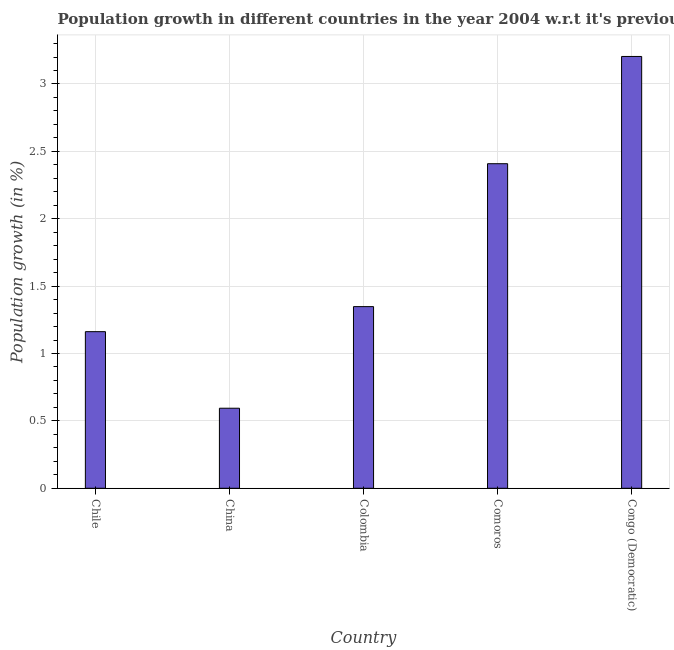Does the graph contain any zero values?
Provide a short and direct response. No. Does the graph contain grids?
Keep it short and to the point. Yes. What is the title of the graph?
Provide a short and direct response. Population growth in different countries in the year 2004 w.r.t it's previous year. What is the label or title of the Y-axis?
Keep it short and to the point. Population growth (in %). What is the population growth in Congo (Democratic)?
Give a very brief answer. 3.2. Across all countries, what is the maximum population growth?
Keep it short and to the point. 3.2. Across all countries, what is the minimum population growth?
Offer a very short reply. 0.59. In which country was the population growth maximum?
Keep it short and to the point. Congo (Democratic). In which country was the population growth minimum?
Keep it short and to the point. China. What is the sum of the population growth?
Give a very brief answer. 8.72. What is the difference between the population growth in Chile and Comoros?
Give a very brief answer. -1.25. What is the average population growth per country?
Provide a short and direct response. 1.74. What is the median population growth?
Your response must be concise. 1.35. What is the ratio of the population growth in Colombia to that in Congo (Democratic)?
Your answer should be compact. 0.42. What is the difference between the highest and the second highest population growth?
Give a very brief answer. 0.8. What is the difference between the highest and the lowest population growth?
Make the answer very short. 2.61. What is the Population growth (in %) of Chile?
Provide a short and direct response. 1.16. What is the Population growth (in %) of China?
Make the answer very short. 0.59. What is the Population growth (in %) of Colombia?
Provide a short and direct response. 1.35. What is the Population growth (in %) in Comoros?
Make the answer very short. 2.41. What is the Population growth (in %) of Congo (Democratic)?
Make the answer very short. 3.2. What is the difference between the Population growth (in %) in Chile and China?
Your answer should be very brief. 0.57. What is the difference between the Population growth (in %) in Chile and Colombia?
Your response must be concise. -0.19. What is the difference between the Population growth (in %) in Chile and Comoros?
Make the answer very short. -1.25. What is the difference between the Population growth (in %) in Chile and Congo (Democratic)?
Provide a succinct answer. -2.04. What is the difference between the Population growth (in %) in China and Colombia?
Your answer should be very brief. -0.75. What is the difference between the Population growth (in %) in China and Comoros?
Your answer should be very brief. -1.81. What is the difference between the Population growth (in %) in China and Congo (Democratic)?
Keep it short and to the point. -2.61. What is the difference between the Population growth (in %) in Colombia and Comoros?
Give a very brief answer. -1.06. What is the difference between the Population growth (in %) in Colombia and Congo (Democratic)?
Your response must be concise. -1.86. What is the difference between the Population growth (in %) in Comoros and Congo (Democratic)?
Offer a terse response. -0.8. What is the ratio of the Population growth (in %) in Chile to that in China?
Keep it short and to the point. 1.96. What is the ratio of the Population growth (in %) in Chile to that in Colombia?
Your answer should be very brief. 0.86. What is the ratio of the Population growth (in %) in Chile to that in Comoros?
Provide a short and direct response. 0.48. What is the ratio of the Population growth (in %) in Chile to that in Congo (Democratic)?
Your answer should be compact. 0.36. What is the ratio of the Population growth (in %) in China to that in Colombia?
Your answer should be compact. 0.44. What is the ratio of the Population growth (in %) in China to that in Comoros?
Offer a terse response. 0.25. What is the ratio of the Population growth (in %) in China to that in Congo (Democratic)?
Your answer should be compact. 0.18. What is the ratio of the Population growth (in %) in Colombia to that in Comoros?
Offer a very short reply. 0.56. What is the ratio of the Population growth (in %) in Colombia to that in Congo (Democratic)?
Make the answer very short. 0.42. What is the ratio of the Population growth (in %) in Comoros to that in Congo (Democratic)?
Make the answer very short. 0.75. 